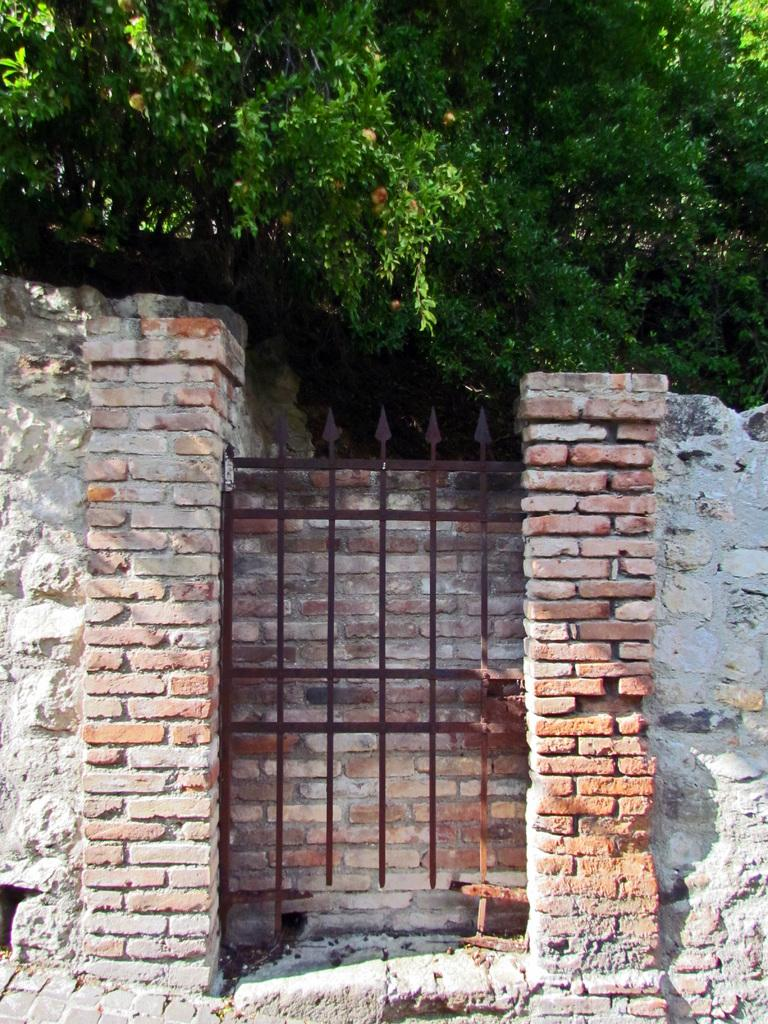What structures can be seen in the image? There are two brick pillars and a gate in the image. What type of vegetation is visible at the top of the image? There are green color trees visible at the top of the image. What is the feeling of the floor in the image? The image does not show a floor, so it is not possible to determine the feeling of the floor. 